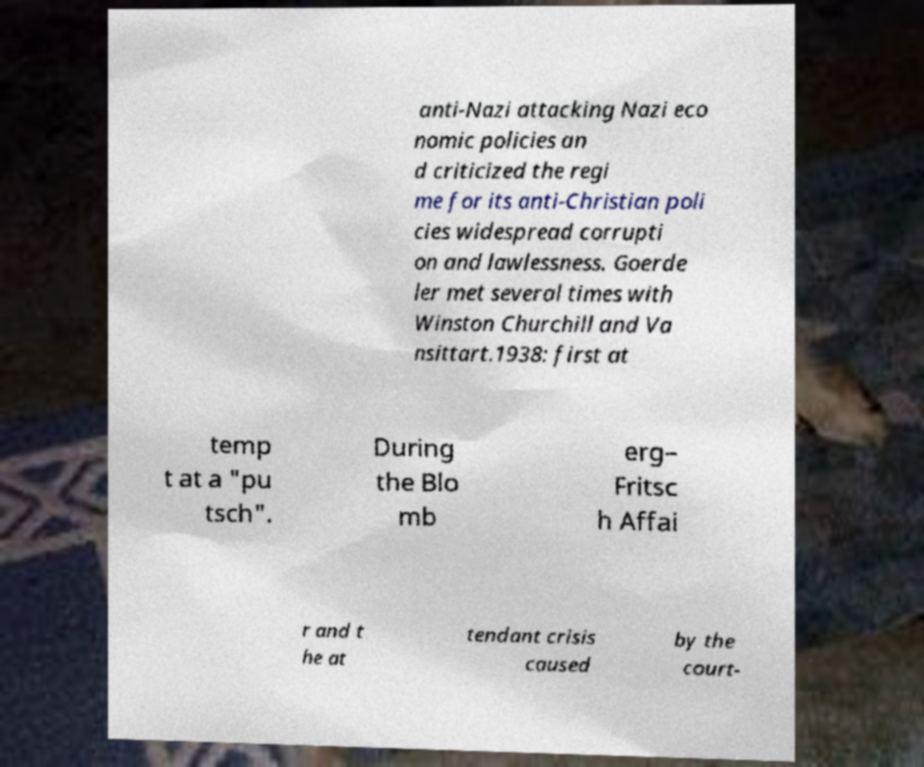Could you extract and type out the text from this image? anti-Nazi attacking Nazi eco nomic policies an d criticized the regi me for its anti-Christian poli cies widespread corrupti on and lawlessness. Goerde ler met several times with Winston Churchill and Va nsittart.1938: first at temp t at a "pu tsch". During the Blo mb erg– Fritsc h Affai r and t he at tendant crisis caused by the court- 